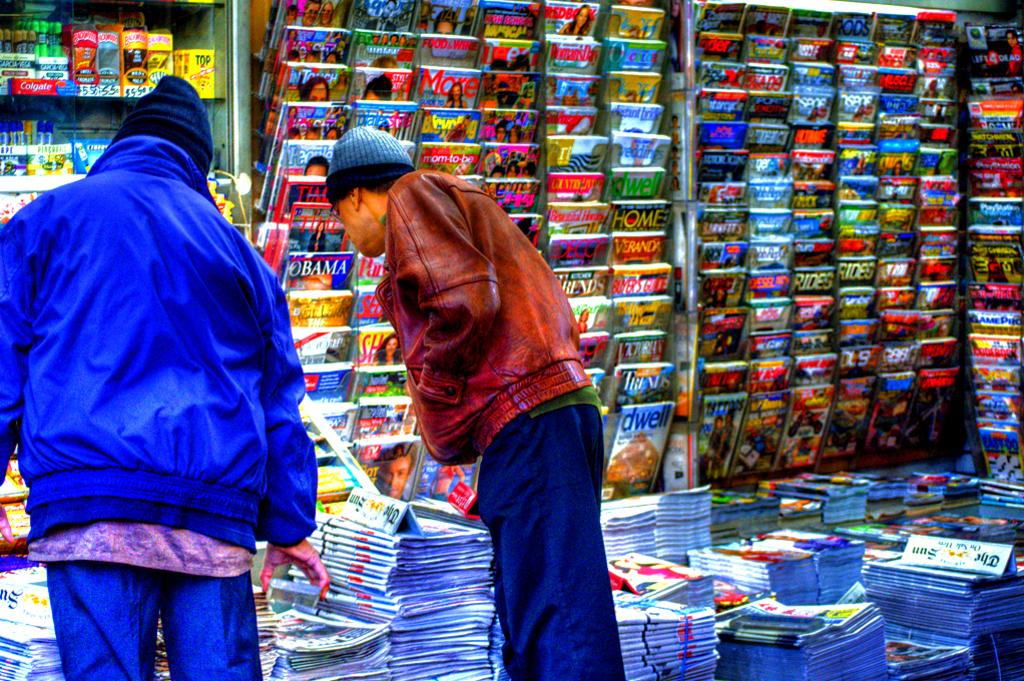<image>
Render a clear and concise summary of the photo. 2 people looking at magazines with brands such as Time 